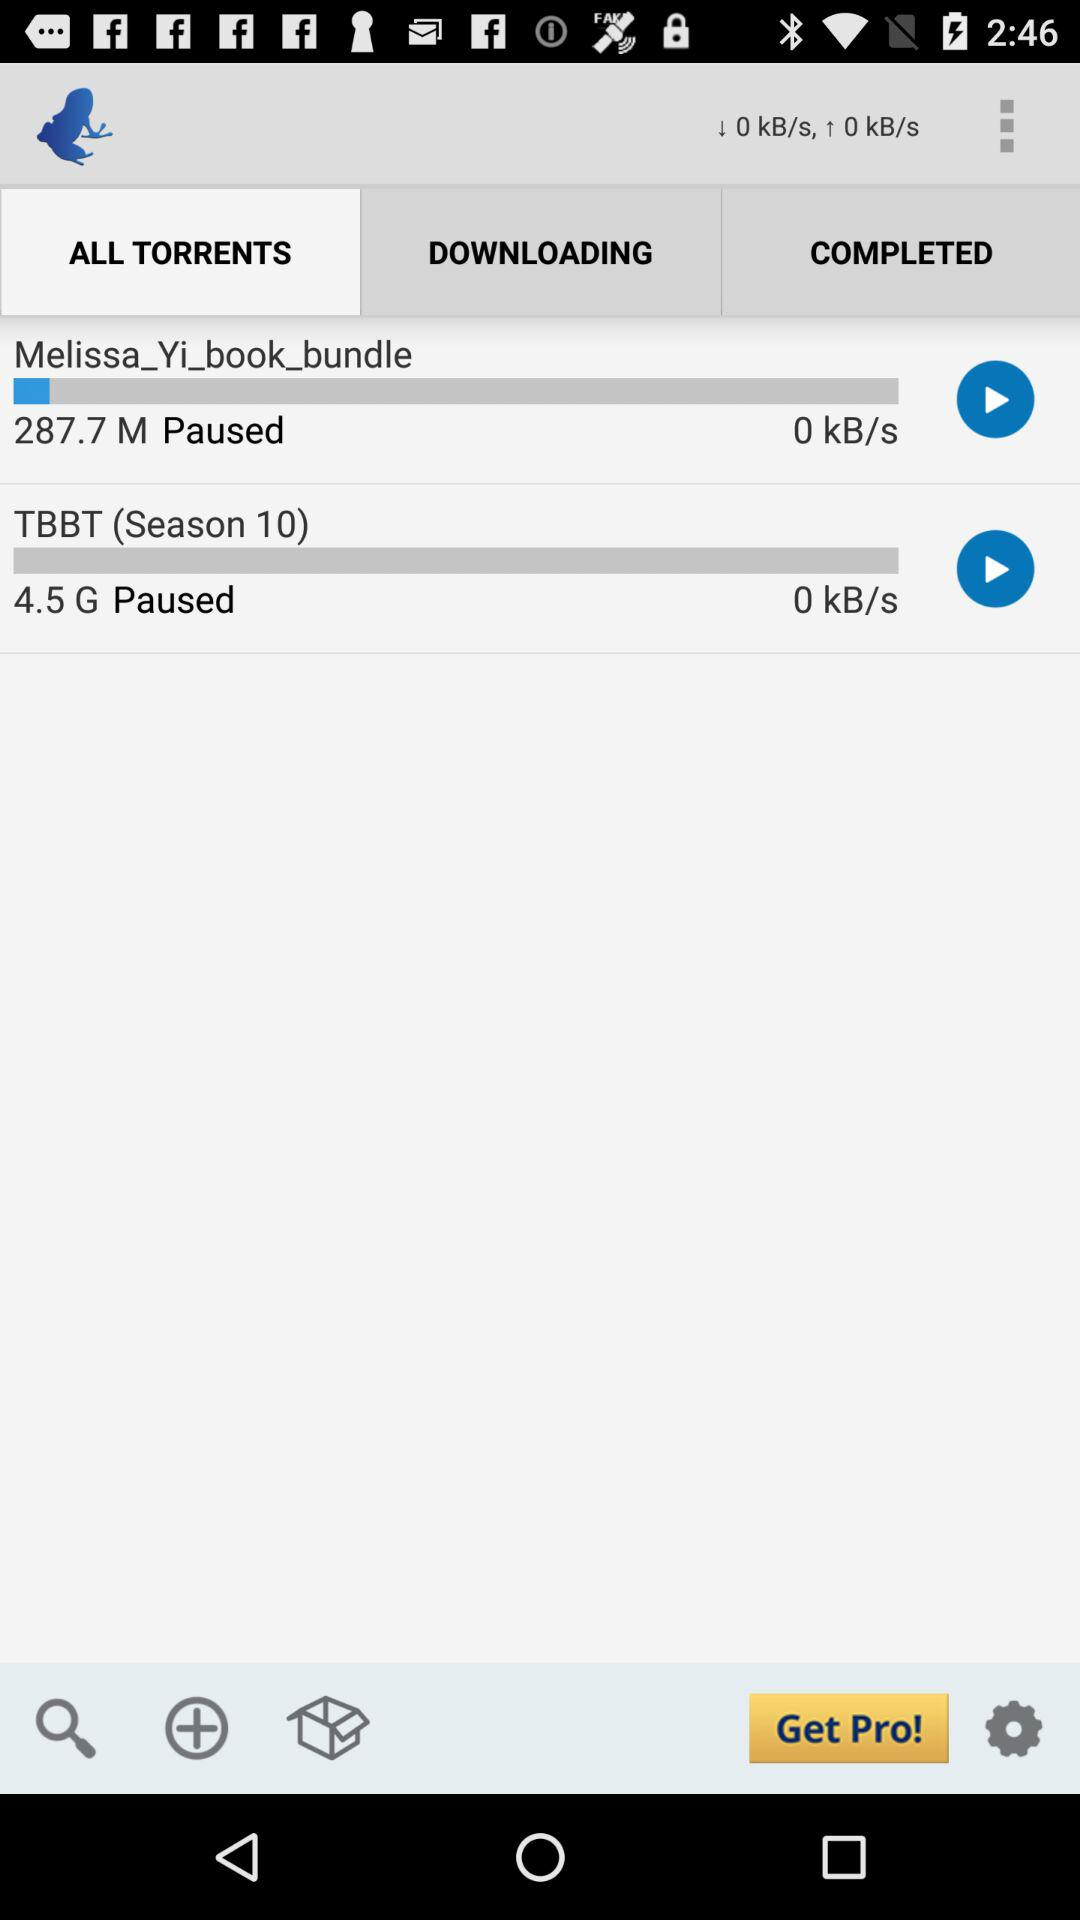What is the size of the "Melissa_Yi_book_bundle" file? The size of the "Melissa_Yi_book_bundle" file is 287.7 M. 